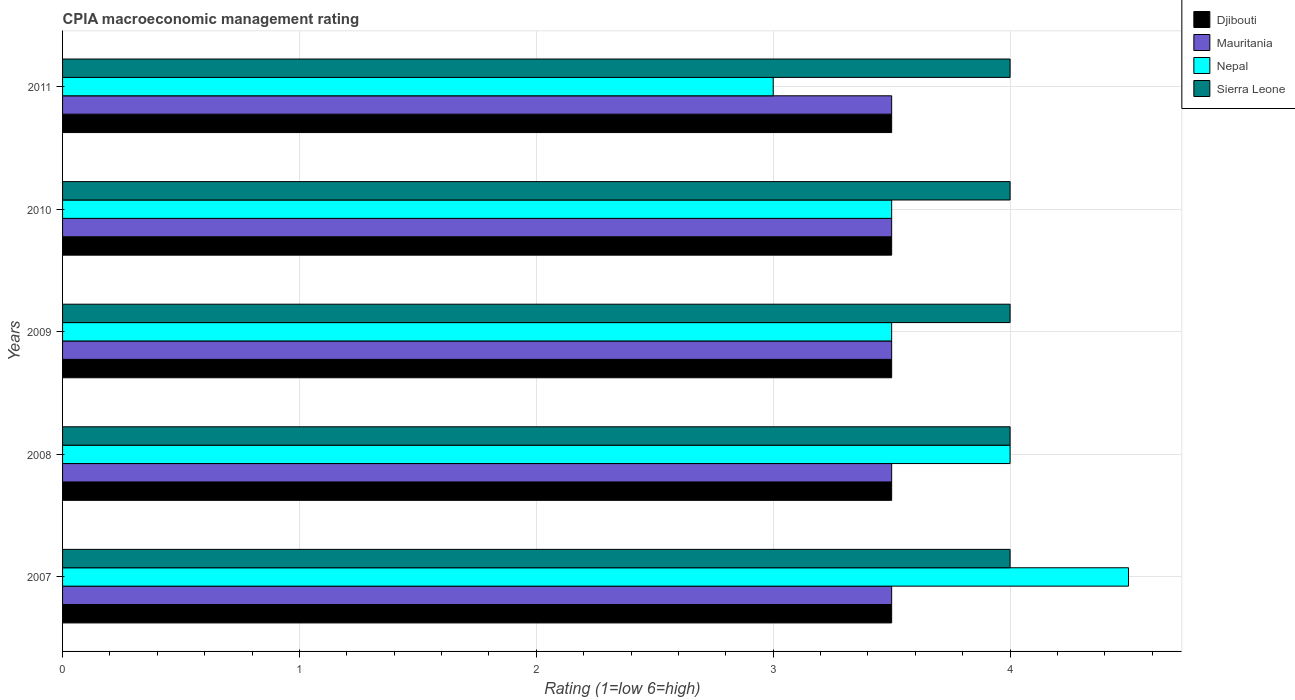Are the number of bars per tick equal to the number of legend labels?
Provide a succinct answer. Yes. What is the CPIA rating in Djibouti in 2010?
Make the answer very short. 3.5. Across all years, what is the maximum CPIA rating in Mauritania?
Make the answer very short. 3.5. Across all years, what is the minimum CPIA rating in Sierra Leone?
Your response must be concise. 4. What is the total CPIA rating in Nepal in the graph?
Your answer should be compact. 18.5. What is the difference between the CPIA rating in Sierra Leone in 2011 and the CPIA rating in Djibouti in 2008?
Give a very brief answer. 0.5. What is the average CPIA rating in Nepal per year?
Offer a terse response. 3.7. In the year 2009, what is the difference between the CPIA rating in Mauritania and CPIA rating in Djibouti?
Your answer should be very brief. 0. Is the difference between the CPIA rating in Mauritania in 2008 and 2009 greater than the difference between the CPIA rating in Djibouti in 2008 and 2009?
Provide a short and direct response. No. What is the difference between the highest and the lowest CPIA rating in Nepal?
Offer a very short reply. 1.5. In how many years, is the CPIA rating in Djibouti greater than the average CPIA rating in Djibouti taken over all years?
Keep it short and to the point. 0. Is the sum of the CPIA rating in Nepal in 2007 and 2008 greater than the maximum CPIA rating in Djibouti across all years?
Keep it short and to the point. Yes. Is it the case that in every year, the sum of the CPIA rating in Djibouti and CPIA rating in Nepal is greater than the sum of CPIA rating in Sierra Leone and CPIA rating in Mauritania?
Your answer should be compact. No. What does the 3rd bar from the top in 2009 represents?
Make the answer very short. Mauritania. What does the 4th bar from the bottom in 2009 represents?
Ensure brevity in your answer.  Sierra Leone. Is it the case that in every year, the sum of the CPIA rating in Djibouti and CPIA rating in Nepal is greater than the CPIA rating in Sierra Leone?
Make the answer very short. Yes. How many years are there in the graph?
Offer a very short reply. 5. Does the graph contain any zero values?
Your response must be concise. No. Does the graph contain grids?
Your response must be concise. Yes. How many legend labels are there?
Offer a very short reply. 4. What is the title of the graph?
Your answer should be very brief. CPIA macroeconomic management rating. Does "Madagascar" appear as one of the legend labels in the graph?
Give a very brief answer. No. What is the label or title of the Y-axis?
Make the answer very short. Years. What is the Rating (1=low 6=high) of Mauritania in 2007?
Keep it short and to the point. 3.5. What is the Rating (1=low 6=high) of Nepal in 2007?
Keep it short and to the point. 4.5. What is the Rating (1=low 6=high) of Sierra Leone in 2007?
Provide a short and direct response. 4. What is the Rating (1=low 6=high) of Djibouti in 2008?
Your answer should be very brief. 3.5. What is the Rating (1=low 6=high) of Djibouti in 2009?
Ensure brevity in your answer.  3.5. What is the Rating (1=low 6=high) in Nepal in 2009?
Make the answer very short. 3.5. What is the Rating (1=low 6=high) of Djibouti in 2010?
Offer a very short reply. 3.5. What is the Rating (1=low 6=high) of Nepal in 2010?
Ensure brevity in your answer.  3.5. What is the Rating (1=low 6=high) in Djibouti in 2011?
Your answer should be very brief. 3.5. Across all years, what is the maximum Rating (1=low 6=high) in Djibouti?
Your answer should be very brief. 3.5. Across all years, what is the minimum Rating (1=low 6=high) of Djibouti?
Offer a very short reply. 3.5. Across all years, what is the minimum Rating (1=low 6=high) of Nepal?
Offer a very short reply. 3. What is the total Rating (1=low 6=high) of Djibouti in the graph?
Your answer should be compact. 17.5. What is the difference between the Rating (1=low 6=high) of Mauritania in 2007 and that in 2008?
Provide a short and direct response. 0. What is the difference between the Rating (1=low 6=high) in Nepal in 2007 and that in 2008?
Offer a terse response. 0.5. What is the difference between the Rating (1=low 6=high) in Sierra Leone in 2007 and that in 2008?
Give a very brief answer. 0. What is the difference between the Rating (1=low 6=high) in Nepal in 2007 and that in 2009?
Make the answer very short. 1. What is the difference between the Rating (1=low 6=high) in Mauritania in 2007 and that in 2010?
Your answer should be very brief. 0. What is the difference between the Rating (1=low 6=high) in Nepal in 2007 and that in 2011?
Offer a very short reply. 1.5. What is the difference between the Rating (1=low 6=high) of Sierra Leone in 2007 and that in 2011?
Your response must be concise. 0. What is the difference between the Rating (1=low 6=high) in Sierra Leone in 2008 and that in 2009?
Ensure brevity in your answer.  0. What is the difference between the Rating (1=low 6=high) in Mauritania in 2008 and that in 2010?
Keep it short and to the point. 0. What is the difference between the Rating (1=low 6=high) in Sierra Leone in 2008 and that in 2010?
Provide a succinct answer. 0. What is the difference between the Rating (1=low 6=high) of Djibouti in 2008 and that in 2011?
Give a very brief answer. 0. What is the difference between the Rating (1=low 6=high) of Nepal in 2008 and that in 2011?
Offer a very short reply. 1. What is the difference between the Rating (1=low 6=high) in Sierra Leone in 2008 and that in 2011?
Make the answer very short. 0. What is the difference between the Rating (1=low 6=high) of Djibouti in 2009 and that in 2010?
Give a very brief answer. 0. What is the difference between the Rating (1=low 6=high) of Mauritania in 2009 and that in 2010?
Your answer should be compact. 0. What is the difference between the Rating (1=low 6=high) in Nepal in 2009 and that in 2010?
Give a very brief answer. 0. What is the difference between the Rating (1=low 6=high) in Sierra Leone in 2009 and that in 2010?
Your answer should be very brief. 0. What is the difference between the Rating (1=low 6=high) of Djibouti in 2009 and that in 2011?
Offer a very short reply. 0. What is the difference between the Rating (1=low 6=high) in Sierra Leone in 2009 and that in 2011?
Your response must be concise. 0. What is the difference between the Rating (1=low 6=high) of Mauritania in 2010 and that in 2011?
Provide a short and direct response. 0. What is the difference between the Rating (1=low 6=high) of Djibouti in 2007 and the Rating (1=low 6=high) of Mauritania in 2008?
Provide a succinct answer. 0. What is the difference between the Rating (1=low 6=high) in Djibouti in 2007 and the Rating (1=low 6=high) in Sierra Leone in 2008?
Ensure brevity in your answer.  -0.5. What is the difference between the Rating (1=low 6=high) in Nepal in 2007 and the Rating (1=low 6=high) in Sierra Leone in 2008?
Provide a succinct answer. 0.5. What is the difference between the Rating (1=low 6=high) in Djibouti in 2007 and the Rating (1=low 6=high) in Mauritania in 2009?
Provide a short and direct response. 0. What is the difference between the Rating (1=low 6=high) in Djibouti in 2007 and the Rating (1=low 6=high) in Nepal in 2009?
Offer a terse response. 0. What is the difference between the Rating (1=low 6=high) in Mauritania in 2007 and the Rating (1=low 6=high) in Nepal in 2009?
Provide a succinct answer. 0. What is the difference between the Rating (1=low 6=high) of Nepal in 2007 and the Rating (1=low 6=high) of Sierra Leone in 2009?
Ensure brevity in your answer.  0.5. What is the difference between the Rating (1=low 6=high) of Djibouti in 2007 and the Rating (1=low 6=high) of Mauritania in 2010?
Provide a short and direct response. 0. What is the difference between the Rating (1=low 6=high) of Djibouti in 2007 and the Rating (1=low 6=high) of Nepal in 2010?
Give a very brief answer. 0. What is the difference between the Rating (1=low 6=high) in Djibouti in 2007 and the Rating (1=low 6=high) in Sierra Leone in 2010?
Your response must be concise. -0.5. What is the difference between the Rating (1=low 6=high) in Djibouti in 2007 and the Rating (1=low 6=high) in Nepal in 2011?
Provide a succinct answer. 0.5. What is the difference between the Rating (1=low 6=high) in Mauritania in 2007 and the Rating (1=low 6=high) in Nepal in 2011?
Give a very brief answer. 0.5. What is the difference between the Rating (1=low 6=high) of Mauritania in 2008 and the Rating (1=low 6=high) of Sierra Leone in 2009?
Keep it short and to the point. -0.5. What is the difference between the Rating (1=low 6=high) in Nepal in 2008 and the Rating (1=low 6=high) in Sierra Leone in 2009?
Provide a succinct answer. 0. What is the difference between the Rating (1=low 6=high) in Djibouti in 2008 and the Rating (1=low 6=high) in Mauritania in 2010?
Your answer should be very brief. 0. What is the difference between the Rating (1=low 6=high) in Djibouti in 2008 and the Rating (1=low 6=high) in Nepal in 2010?
Ensure brevity in your answer.  0. What is the difference between the Rating (1=low 6=high) in Djibouti in 2008 and the Rating (1=low 6=high) in Sierra Leone in 2010?
Make the answer very short. -0.5. What is the difference between the Rating (1=low 6=high) of Mauritania in 2008 and the Rating (1=low 6=high) of Sierra Leone in 2010?
Make the answer very short. -0.5. What is the difference between the Rating (1=low 6=high) in Djibouti in 2008 and the Rating (1=low 6=high) in Mauritania in 2011?
Provide a succinct answer. 0. What is the difference between the Rating (1=low 6=high) of Djibouti in 2008 and the Rating (1=low 6=high) of Sierra Leone in 2011?
Ensure brevity in your answer.  -0.5. What is the difference between the Rating (1=low 6=high) in Mauritania in 2008 and the Rating (1=low 6=high) in Nepal in 2011?
Offer a very short reply. 0.5. What is the difference between the Rating (1=low 6=high) of Djibouti in 2009 and the Rating (1=low 6=high) of Nepal in 2010?
Your response must be concise. 0. What is the difference between the Rating (1=low 6=high) in Djibouti in 2009 and the Rating (1=low 6=high) in Sierra Leone in 2010?
Make the answer very short. -0.5. What is the difference between the Rating (1=low 6=high) in Mauritania in 2009 and the Rating (1=low 6=high) in Nepal in 2010?
Offer a very short reply. 0. What is the difference between the Rating (1=low 6=high) in Mauritania in 2009 and the Rating (1=low 6=high) in Sierra Leone in 2010?
Your answer should be very brief. -0.5. What is the difference between the Rating (1=low 6=high) in Djibouti in 2009 and the Rating (1=low 6=high) in Mauritania in 2011?
Keep it short and to the point. 0. What is the difference between the Rating (1=low 6=high) in Djibouti in 2009 and the Rating (1=low 6=high) in Nepal in 2011?
Ensure brevity in your answer.  0.5. What is the difference between the Rating (1=low 6=high) of Djibouti in 2009 and the Rating (1=low 6=high) of Sierra Leone in 2011?
Your answer should be very brief. -0.5. What is the difference between the Rating (1=low 6=high) of Nepal in 2009 and the Rating (1=low 6=high) of Sierra Leone in 2011?
Make the answer very short. -0.5. What is the difference between the Rating (1=low 6=high) of Djibouti in 2010 and the Rating (1=low 6=high) of Sierra Leone in 2011?
Offer a terse response. -0.5. What is the difference between the Rating (1=low 6=high) in Mauritania in 2010 and the Rating (1=low 6=high) in Sierra Leone in 2011?
Your response must be concise. -0.5. What is the average Rating (1=low 6=high) of Djibouti per year?
Offer a terse response. 3.5. What is the average Rating (1=low 6=high) in Mauritania per year?
Offer a very short reply. 3.5. What is the average Rating (1=low 6=high) of Nepal per year?
Provide a succinct answer. 3.7. In the year 2007, what is the difference between the Rating (1=low 6=high) in Djibouti and Rating (1=low 6=high) in Mauritania?
Your answer should be very brief. 0. In the year 2007, what is the difference between the Rating (1=low 6=high) of Djibouti and Rating (1=low 6=high) of Nepal?
Provide a short and direct response. -1. In the year 2007, what is the difference between the Rating (1=low 6=high) of Djibouti and Rating (1=low 6=high) of Sierra Leone?
Your answer should be compact. -0.5. In the year 2007, what is the difference between the Rating (1=low 6=high) in Mauritania and Rating (1=low 6=high) in Nepal?
Keep it short and to the point. -1. In the year 2007, what is the difference between the Rating (1=low 6=high) in Mauritania and Rating (1=low 6=high) in Sierra Leone?
Your response must be concise. -0.5. In the year 2008, what is the difference between the Rating (1=low 6=high) of Djibouti and Rating (1=low 6=high) of Mauritania?
Offer a terse response. 0. In the year 2008, what is the difference between the Rating (1=low 6=high) in Djibouti and Rating (1=low 6=high) in Nepal?
Keep it short and to the point. -0.5. In the year 2008, what is the difference between the Rating (1=low 6=high) in Mauritania and Rating (1=low 6=high) in Nepal?
Provide a short and direct response. -0.5. In the year 2008, what is the difference between the Rating (1=low 6=high) of Mauritania and Rating (1=low 6=high) of Sierra Leone?
Your answer should be very brief. -0.5. In the year 2008, what is the difference between the Rating (1=low 6=high) in Nepal and Rating (1=low 6=high) in Sierra Leone?
Offer a very short reply. 0. In the year 2009, what is the difference between the Rating (1=low 6=high) in Mauritania and Rating (1=low 6=high) in Nepal?
Offer a terse response. 0. In the year 2010, what is the difference between the Rating (1=low 6=high) of Mauritania and Rating (1=low 6=high) of Nepal?
Provide a succinct answer. 0. In the year 2010, what is the difference between the Rating (1=low 6=high) in Mauritania and Rating (1=low 6=high) in Sierra Leone?
Provide a succinct answer. -0.5. In the year 2011, what is the difference between the Rating (1=low 6=high) in Djibouti and Rating (1=low 6=high) in Mauritania?
Your response must be concise. 0. In the year 2011, what is the difference between the Rating (1=low 6=high) in Djibouti and Rating (1=low 6=high) in Nepal?
Make the answer very short. 0.5. In the year 2011, what is the difference between the Rating (1=low 6=high) in Djibouti and Rating (1=low 6=high) in Sierra Leone?
Your answer should be very brief. -0.5. In the year 2011, what is the difference between the Rating (1=low 6=high) in Mauritania and Rating (1=low 6=high) in Nepal?
Offer a very short reply. 0.5. In the year 2011, what is the difference between the Rating (1=low 6=high) of Mauritania and Rating (1=low 6=high) of Sierra Leone?
Your response must be concise. -0.5. What is the ratio of the Rating (1=low 6=high) in Djibouti in 2007 to that in 2008?
Your answer should be very brief. 1. What is the ratio of the Rating (1=low 6=high) of Sierra Leone in 2007 to that in 2008?
Make the answer very short. 1. What is the ratio of the Rating (1=low 6=high) of Djibouti in 2007 to that in 2009?
Provide a short and direct response. 1. What is the ratio of the Rating (1=low 6=high) in Mauritania in 2007 to that in 2009?
Your answer should be very brief. 1. What is the ratio of the Rating (1=low 6=high) in Nepal in 2007 to that in 2009?
Provide a short and direct response. 1.29. What is the ratio of the Rating (1=low 6=high) in Nepal in 2007 to that in 2010?
Ensure brevity in your answer.  1.29. What is the ratio of the Rating (1=low 6=high) in Sierra Leone in 2007 to that in 2010?
Provide a succinct answer. 1. What is the ratio of the Rating (1=low 6=high) in Djibouti in 2007 to that in 2011?
Provide a short and direct response. 1. What is the ratio of the Rating (1=low 6=high) of Mauritania in 2007 to that in 2011?
Ensure brevity in your answer.  1. What is the ratio of the Rating (1=low 6=high) in Djibouti in 2008 to that in 2009?
Provide a short and direct response. 1. What is the ratio of the Rating (1=low 6=high) in Mauritania in 2008 to that in 2009?
Provide a short and direct response. 1. What is the ratio of the Rating (1=low 6=high) in Nepal in 2008 to that in 2009?
Provide a short and direct response. 1.14. What is the ratio of the Rating (1=low 6=high) of Nepal in 2008 to that in 2010?
Provide a short and direct response. 1.14. What is the ratio of the Rating (1=low 6=high) in Sierra Leone in 2008 to that in 2010?
Keep it short and to the point. 1. What is the ratio of the Rating (1=low 6=high) of Nepal in 2008 to that in 2011?
Keep it short and to the point. 1.33. What is the ratio of the Rating (1=low 6=high) of Djibouti in 2009 to that in 2010?
Your answer should be compact. 1. What is the ratio of the Rating (1=low 6=high) of Mauritania in 2009 to that in 2010?
Ensure brevity in your answer.  1. What is the ratio of the Rating (1=low 6=high) in Sierra Leone in 2009 to that in 2010?
Provide a succinct answer. 1. What is the ratio of the Rating (1=low 6=high) of Djibouti in 2009 to that in 2011?
Offer a very short reply. 1. What is the ratio of the Rating (1=low 6=high) of Mauritania in 2009 to that in 2011?
Your response must be concise. 1. What is the ratio of the Rating (1=low 6=high) of Nepal in 2009 to that in 2011?
Offer a terse response. 1.17. What is the ratio of the Rating (1=low 6=high) in Sierra Leone in 2009 to that in 2011?
Ensure brevity in your answer.  1. What is the ratio of the Rating (1=low 6=high) of Djibouti in 2010 to that in 2011?
Give a very brief answer. 1. What is the ratio of the Rating (1=low 6=high) of Nepal in 2010 to that in 2011?
Provide a succinct answer. 1.17. What is the ratio of the Rating (1=low 6=high) in Sierra Leone in 2010 to that in 2011?
Give a very brief answer. 1. What is the difference between the highest and the second highest Rating (1=low 6=high) in Djibouti?
Provide a short and direct response. 0. What is the difference between the highest and the second highest Rating (1=low 6=high) in Mauritania?
Offer a terse response. 0. What is the difference between the highest and the second highest Rating (1=low 6=high) of Sierra Leone?
Give a very brief answer. 0. What is the difference between the highest and the lowest Rating (1=low 6=high) of Nepal?
Give a very brief answer. 1.5. 